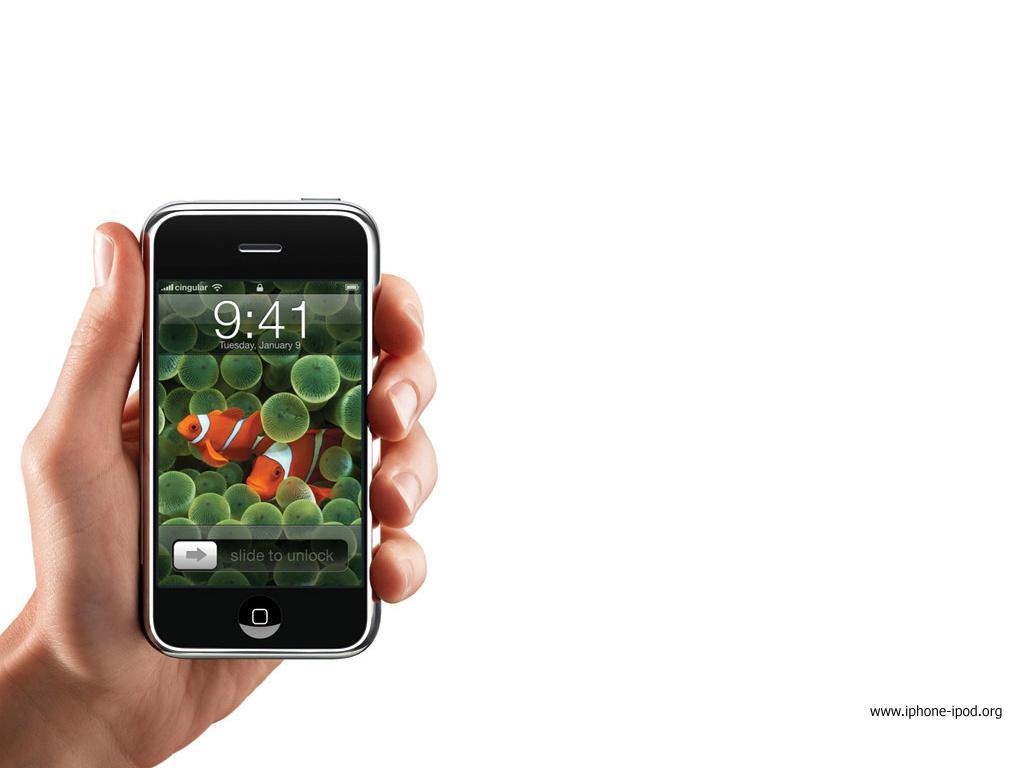In one or two sentences, can you explain what this image depicts? On the left side of the image we can see a hand holding a mobile. At the bottom right corner there is a text. 